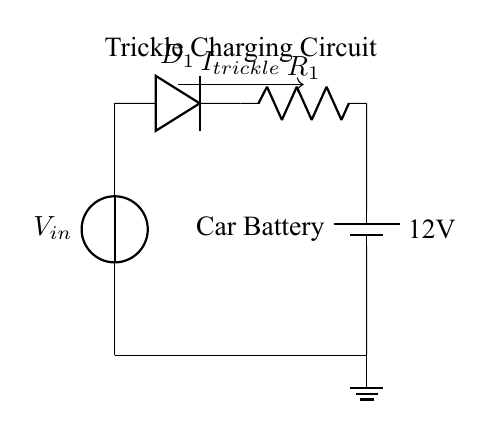What is the voltage source in this circuit? The voltage source is labeled as V_in at the top of the circuit diagram and provides the input voltage.
Answer: V_in What component limits the current flow in this circuit? The resistor is labeled as R_1, and its role is to limit current flow within the circuit.
Answer: R_1 What is the purpose of the diode in this trickle charging circuit? The diode, labeled D_1, is used to allow current to flow in only one direction, preventing reverse current that could damage the battery.
Answer: D_1 How many main components are there in this trickle charging circuit? The circuit contains four main components: a voltage source, a diode, a resistor, and a car battery.
Answer: Four What type of charging does this circuit perform? The circuit is specifically designed for trickle charging to maintain the battery during long periods of inactivity.
Answer: Trickle charging What is the direction of the current flow in this circuit? The current flow is indicated by the arrow labeled I_trickle, which shows the direction from the diode to the battery.
Answer: From diode to battery 